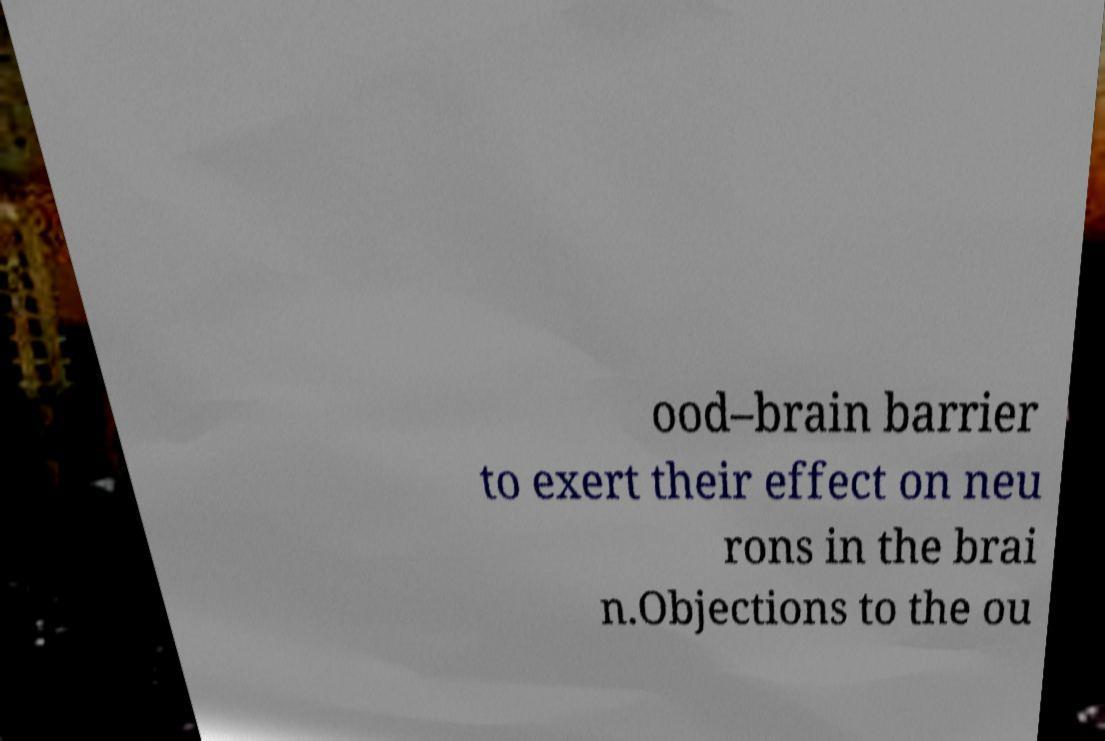Could you assist in decoding the text presented in this image and type it out clearly? ood–brain barrier to exert their effect on neu rons in the brai n.Objections to the ou 